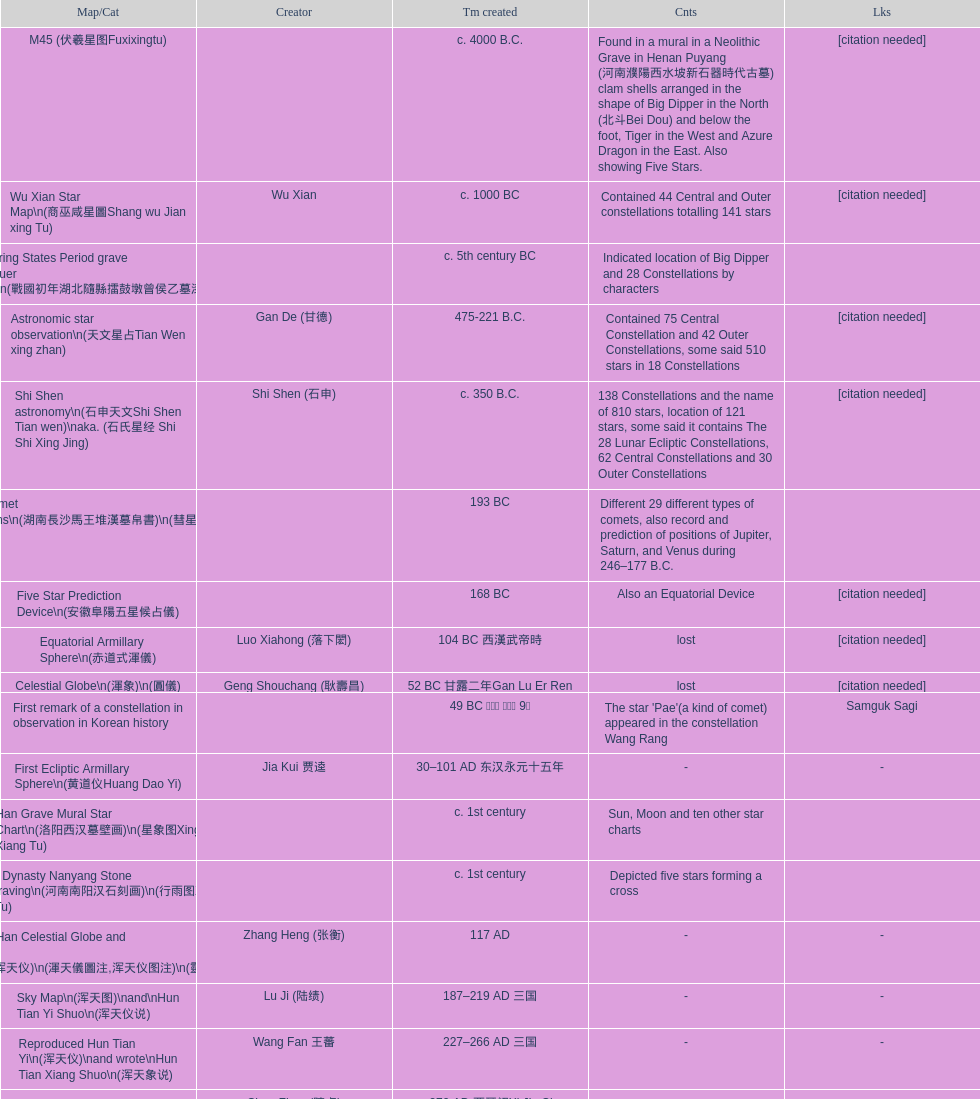Parse the full table. {'header': ['Map/Cat', 'Creator', 'Tm created', 'Cnts', 'Lks'], 'rows': [['M45 (伏羲星图Fuxixingtu)', '', 'c. 4000 B.C.', 'Found in a mural in a Neolithic Grave in Henan Puyang (河南濮陽西水坡新石器時代古墓) clam shells arranged in the shape of Big Dipper in the North (北斗Bei Dou) and below the foot, Tiger in the West and Azure Dragon in the East. Also showing Five Stars.', '[citation needed]'], ['Wu Xian Star Map\\n(商巫咸星圖Shang wu Jian xing Tu)', 'Wu Xian', 'c. 1000 BC', 'Contained 44 Central and Outer constellations totalling 141 stars', '[citation needed]'], ['Warring States Period grave lacquer box\\n(戰國初年湖北隨縣擂鼓墩曾侯乙墓漆箱)', '', 'c. 5th century BC', 'Indicated location of Big Dipper and 28 Constellations by characters', ''], ['Astronomic star observation\\n(天文星占Tian Wen xing zhan)', 'Gan De (甘德)', '475-221 B.C.', 'Contained 75 Central Constellation and 42 Outer Constellations, some said 510 stars in 18 Constellations', '[citation needed]'], ['Shi Shen astronomy\\n(石申天文Shi Shen Tian wen)\\naka. (石氏星经 Shi Shi Xing Jing)', 'Shi Shen (石申)', 'c. 350 B.C.', '138 Constellations and the name of 810 stars, location of 121 stars, some said it contains The 28 Lunar Ecliptic Constellations, 62 Central Constellations and 30 Outer Constellations', '[citation needed]'], ['Han Comet Diagrams\\n(湖南長沙馬王堆漢墓帛書)\\n(彗星圖Meng xing Tu)', '', '193 BC', 'Different 29 different types of comets, also record and prediction of positions of Jupiter, Saturn, and Venus during 246–177 B.C.', ''], ['Five Star Prediction Device\\n(安徽阜陽五星候占儀)', '', '168 BC', 'Also an Equatorial Device', '[citation needed]'], ['Equatorial Armillary Sphere\\n(赤道式渾儀)', 'Luo Xiahong (落下閎)', '104 BC 西漢武帝時', 'lost', '[citation needed]'], ['Celestial Globe\\n(渾象)\\n(圓儀)', 'Geng Shouchang (耿壽昌)', '52 BC 甘露二年Gan Lu Er Ren', 'lost', '[citation needed]'], ['First remark of a constellation in observation in Korean history', '', '49 BC 혁거세 거서간 9년', "The star 'Pae'(a kind of comet) appeared in the constellation Wang Rang", 'Samguk Sagi'], ['First Ecliptic Armillary Sphere\\n(黄道仪Huang Dao Yi)', 'Jia Kui 贾逵', '30–101 AD 东汉永元十五年', '-', '-'], ['Han Grave Mural Star Chart\\n(洛阳西汉墓壁画)\\n(星象图Xing Xiang Tu)', '', 'c. 1st century', 'Sun, Moon and ten other star charts', ''], ['Han Dynasty Nanyang Stone Engraving\\n(河南南阳汉石刻画)\\n(行雨图Xing Yu Tu)', '', 'c. 1st century', 'Depicted five stars forming a cross', ''], ['Eastern Han Celestial Globe and star maps\\n(浑天仪)\\n(渾天儀圖注,浑天仪图注)\\n(靈憲,灵宪)', 'Zhang Heng (张衡)', '117 AD', '-', '-'], ['Sky Map\\n(浑天图)\\nand\\nHun Tian Yi Shuo\\n(浑天仪说)', 'Lu Ji (陆绩)', '187–219 AD 三国', '-', '-'], ['Reproduced Hun Tian Yi\\n(浑天仪)\\nand wrote\\nHun Tian Xiang Shuo\\n(浑天象说)', 'Wang Fan 王蕃', '227–266 AD 三国', '-', '-'], ['Whole Sky Star Maps\\n(全天星圖Quan Tian Xing Tu)', 'Chen Zhuo (陳卓)', 'c. 270 AD 西晉初Xi Jin Chu', 'A Unified Constellation System. Star maps containing 1464 stars in 284 Constellations, written astrology text', '-'], ['Equatorial Armillary Sphere\\n(渾儀Hun Xi)', 'Kong Ting (孔挺)', '323 AD 東晉 前趙光初六年', 'level being used in this kind of device', '-'], ['Northern Wei Period Iron Armillary Sphere\\n(鐵渾儀)', 'Hu Lan (斛蘭)', 'Bei Wei\\plevel being used in this kind of device', '-', ''], ['Southern Dynasties Period Whole Sky Planetarium\\n(渾天象Hun Tian Xiang)', 'Qian Lezhi (錢樂之)', '443 AD 南朝劉宋元嘉年間', 'used red, black and white to differentiate stars from different star maps from Shi Shen, Gan De and Wu Xian 甘, 石, 巫三家星', '-'], ['Northern Wei Grave Dome Star Map\\n(河南洛陽北魏墓頂星圖)', '', '526 AD 北魏孝昌二年', 'about 300 stars, including the Big Dipper, some stars are linked by straight lines to form constellation. The Milky Way is also shown.', ''], ['Water-powered Planetarium\\n(水力渾天儀)', 'Geng Xun (耿詢)', 'c. 7th century 隋初Sui Chu', '-', '-'], ['Lingtai Miyuan\\n(靈台秘苑)', 'Yu Jicai (庾季才) and Zhou Fen (周墳)', '604 AD 隋Sui', 'incorporated star maps from different sources', '-'], ['Tang Dynasty Whole Sky Ecliptic Armillary Sphere\\n(渾天黃道儀)', 'Li Chunfeng 李淳風', '667 AD 貞觀七年', 'including Elliptic and Moon orbit, in addition to old equatorial design', '-'], ['The Dunhuang star map\\n(燉煌)', 'Dun Huang', '705–710 AD', '1,585 stars grouped into 257 clusters or "asterisms"', ''], ['Turfan Tomb Star Mural\\n(新疆吐鲁番阿斯塔那天文壁画)', '', '250–799 AD 唐', '28 Constellations, Milkyway and Five Stars', ''], ['Picture of Fuxi and Nüwa 新疆阿斯達那唐墓伏羲Fu Xi 女媧NV Wa像Xiang', '', 'Tang Dynasty', 'Picture of Fuxi and Nuwa together with some constellations', 'Image:Nuva fuxi.gif'], ['Tang Dynasty Armillary Sphere\\n(唐代渾儀Tang Dai Hun Xi)\\n(黃道遊儀Huang dao you xi)', 'Yixing Monk 一行和尚 (张遂)Zhang Sui and Liang Lingzan 梁令瓚', '683–727 AD', 'based on Han Dynasty Celestial Globe, recalibrated locations of 150 stars, determined that stars are moving', ''], ['Tang Dynasty Indian Horoscope Chart\\n(梵天火羅九曜)', 'Yixing Priest 一行和尚 (张遂)\\pZhang Sui\\p683–727 AD', 'simple diagrams of the 28 Constellation', '', ''], ['Kitora Kofun 法隆寺FaLong Si\u3000キトラ古墳 in Japan', '', 'c. late 7th century – early 8th century', 'Detailed whole sky map', ''], ['Treatise on Astrology of the Kaiyuan Era\\n(開元占経,开元占经Kai Yuan zhang Jing)', 'Gautama Siddha', '713 AD –', 'Collection of the three old star charts from Shi Shen, Gan De and Wu Xian. One of the most renowned collection recognized academically.', '-'], ['Big Dipper\\n(山東嘉祥武梁寺石刻北斗星)', '', '–', 'showing stars in Big Dipper', ''], ['Prajvalonisa Vjrabhairava Padvinasa-sri-dharani Scroll found in Japan 熾盛光佛頂大威德銷災吉祥陀羅尼經卷首扉畫', '', '972 AD 北宋開寶五年', 'Chinese 28 Constellations and Western Zodiac', '-'], ['Tangut Khara-Khoto (The Black City) Star Map 西夏黑水城星圖', '', '940 AD', 'A typical Qian Lezhi Style Star Map', '-'], ['Star Chart 五代吳越文穆王前元瓘墓石刻星象圖', '', '941–960 AD', '-', ''], ['Ancient Star Map 先天图 by 陈抟Chen Tuan', '', 'c. 11th Chen Tuan 宋Song', 'Perhaps based on studying of Puyong Ancient Star Map', 'Lost'], ['Song Dynasty Bronze Armillary Sphere 北宋至道銅渾儀', 'Han Xianfu 韓顯符', '1006 AD 宋道元年十二月', 'Similar to the Simplified Armillary by Kong Ting 孔挺, 晁崇 Chao Chong, 斛蘭 Hu Lan', '-'], ['Song Dynasty Bronze Armillary Sphere 北宋天文院黄道渾儀', 'Shu Yijian 舒易簡, Yu Yuan 于渊, Zhou Cong 周琮', '宋皇祐年中', 'Similar to the Armillary by Tang Dynasty Liang Lingzan 梁令瓚 and Yi Xing 一行', '-'], ['Song Dynasty Armillary Sphere 北宋簡化渾儀', 'Shen Kuo 沈括 and Huangfu Yu 皇甫愈', '1089 AD 熙寧七年', 'Simplied version of Tang Dynasty Device, removed the rarely used moon orbit.', '-'], ['Five Star Charts (新儀象法要)', 'Su Song 蘇頌', '1094 AD', '1464 stars grouped into 283 asterisms', 'Image:Su Song Star Map 1.JPG\\nImage:Su Song Star Map 2.JPG'], ['Song Dynasty Water-powered Planetarium 宋代 水运仪象台', 'Su Song 蘇頌 and Han Gonglian 韩公廉', 'c. 11th century', '-', ''], ['Liao Dynasty Tomb Dome Star Map 遼宣化张世卿墓頂星圖', '', '1116 AD 遼天庆六年', 'shown both the Chinese 28 Constellation encircled by Babylonian Zodiac', ''], ["Star Map in a woman's grave (江西德安 南宋周氏墓星相图)", '', '1127–1279 AD', 'Milky Way and 57 other stars.', ''], ['Hun Tian Yi Tong Xing Xiang Quan Tu, Suzhou Star Chart (蘇州石刻天文圖),淳祐天文図', 'Huang Shang (黃裳)', 'created in 1193, etched to stone in 1247 by Wang Zhi Yuan 王致遠', '1434 Stars grouped into 280 Asterisms in Northern Sky map', ''], ['Yuan Dynasty Simplified Armillary Sphere 元代簡儀', 'Guo Shou Jing 郭守敬', '1276–1279', 'Further simplied version of Song Dynasty Device', ''], ['Japanese Star Chart 格子月進図', '', '1324', 'Similar to Su Song Star Chart, original burned in air raids during World War II, only pictures left. Reprinted in 1984 by 佐佐木英治', ''], ['天象列次分野之図(Cheonsang Yeolcha Bunyajido)', '', '1395', 'Korean versions of Star Map in Stone. It was made in Chosun Dynasty and the constellation names were written in Chinese letter. The constellations as this was found in Japanese later. Contained 1,464 stars.', ''], ['Japanese Star Chart 瀧谷寺 天之図', '', 'c. 14th or 15th centuries 室町中期以前', '-', ''], ["Korean King Sejong's Armillary sphere", '', '1433', '-', ''], ['Star Chart', 'Mao Kun 茅坤', 'c. 1422', 'Polaris compared with Southern Cross and Alpha Centauri', 'zh:郑和航海图'], ['Korean Tomb', '', 'c. late 14th century', 'Big Dipper', ''], ['Ming Ancient Star Chart 北京隆福寺(古星圖)', '', 'c. 1453 明代', '1420 Stars, possibly based on old star maps from Tang Dynasty', ''], ['Chanshu Star Chart (明常熟石刻天文圖)', '', '1506', 'Based on Suzhou Star Chart, Northern Sky observed at 36.8 degrees North Latitude, 1466 stars grouped into 284 asterism', '-'], ['Ming Dynasty Star Map (渾蓋通憲圖說)', 'Matteo Ricci 利玛窦Li Ma Dou, recorded by Li Zhizao 李之藻', 'c. 1550', '-', ''], ['Tian Wun Tu (天问图)', 'Xiao Yun Cong 萧云从', 'c. 1600', 'Contained mapping of 12 constellations and 12 animals', ''], ['Zhou Tian Xuan Ji Tu (周天璇玑图) and He He Si Xiang Tu (和合四象圖) in Xing Ming Gui Zhi (性命圭旨)', 'by 尹真人高第弟子 published by 余永宁', '1615', 'Drawings of Armillary Sphere and four Chinese Celestial Animals with some notes. Related to Taoism.', ''], ['Korean Astronomy Book "Selected and Systematized Astronomy Notes" 天文類抄', '', '1623~1649', 'Contained some star maps', ''], ['Ming Dynasty General Star Map (赤道南北兩總星圖)', 'Xu Guang ci 徐光啟 and Adam Schall von Bell Tang Ruo Wang湯若望', '1634', '-', ''], ['Ming Dynasty diagrams of Armillary spheres and Celestial Globes', 'Xu Guang ci 徐光啟', 'c. 1699', '-', ''], ['Ming Dynasty Planetarium Machine (渾象 Hui Xiang)', '', 'c. 17th century', 'Ecliptic, Equator, and dividers of 28 constellation', ''], ['Copper Plate Star Map stored in Korea', '', '1652 順治九年shun zi jiu nian', '-', ''], ['Japanese Edo period Star Chart 天象列次之図 based on 天象列次分野之図 from Korean', 'Harumi Shibukawa 渋川春海Bu Chuan Chun Mei(保井春海Bao Jing Chun Mei)', '1670 寛文十年', '-', ''], ['The Celestial Globe 清康熙 天體儀', 'Ferdinand Verbiest 南懷仁', '1673', '1876 stars grouped into 282 asterisms', ''], ['Picture depicted Song Dynasty fictional astronomer (呉用 Wu Yong) with a Celestial Globe (天體儀)', 'Japanese painter', '1675', 'showing top portion of a Celestial Globe', 'File:Chinese astronomer 1675.jpg'], ['Japanese Edo period Star Chart 天文分野之図', 'Harumi Shibukawa 渋川春海BuJingChun Mei (保井春海Bao JingChunMei)', '1677 延宝五年', '-', ''], ['Korean star map in stone', '', '1687', '-', ''], ['Japanese Edo period Star Chart 天文図解', '井口常範', '1689 元禄2年', '-', '-'], ['Japanese Edo period Star Chart 古暦便覧備考', '苗村丈伯Mao Chun Zhang Bo', '1692 元禄5年', '-', '-'], ['Japanese star chart', 'Harumi Yasui written in Chinese', '1699 AD', 'A Japanese star chart of 1699 showing lunar stations', ''], ['Japanese Edo period Star Chart 天文成象Tian Wen Cheng xiang', '(渋川昔尹She Chuan Xi Yin) (保井昔尹Bao Jing Xi Yin)', '1699 元禄十二年', 'including Stars from Wu Shien (44 Constellation, 144 stars) in yellow; Gan De (118 Constellations, 511 stars) in black; Shi Shen (138 Constellations, 810 stars) in red and Harumi Shibukawa (61 Constellations, 308 stars) in blue;', ''], ['Japanese Star Chart 改正天文図説', '', 'unknown', 'Included stars from Harumi Shibukawa', ''], ['Korean Star Map Stone', '', 'c. 17th century', '-', ''], ['Korean Star Map', '', 'c. 17th century', '-', ''], ['Ceramic Ink Sink Cover', '', 'c. 17th century', 'Showing Big Dipper', ''], ['Korean Star Map Cube 方星圖', 'Italian Missionary Philippus Maria Grimardi 閔明我 (1639~1712)', 'c. early 18th century', '-', ''], ['Star Chart preserved in Japan based on a book from China 天経或問', 'You Zi liu 游子六', '1730 AD 江戸時代 享保15年', 'A Northern Sky Chart in Chinese', ''], ['Star Chart 清蒙文石刻(欽天監繪製天文圖) in Mongolia', '', '1727–1732 AD', '1550 stars grouped into 270 starisms.', ''], ['Korean Star Maps, North and South to the Eclliptic 黃道南北恒星圖', '', '1742', '-', ''], ['Japanese Edo period Star Chart 天経或問註解図巻\u3000下', '入江脩敬Ru Jiang YOu Jing', '1750 寛延3年', '-', '-'], ['Reproduction of an ancient device 璇璣玉衡', 'Dai Zhen 戴震', '1723–1777 AD', 'based on ancient record and his own interpretation', 'Could be similar to'], ['Rock Star Chart 清代天文石', '', 'c. 18th century', 'A Star Chart and general Astronomy Text', ''], ['Korean Complete Star Map (渾天全圖)', '', 'c. 18th century', '-', ''], ['Qing Dynasty Star Catalog (儀象考成,仪象考成)恒星表 and Star Map 黄道南北両星総図', 'Yun Lu 允禄 and Ignatius Kogler 戴进贤Dai Jin Xian 戴進賢, a German', 'Device made in 1744, book completed in 1757 清乾隆年间', '300 Constellations and 3083 Stars. Referenced Star Catalogue published by John Flamsteed', ''], ['Jingban Tianwen Quantu by Ma Junliang 马俊良', '', '1780–90 AD', 'mapping nations to the sky', ''], ['Japanese Edo period Illustration of a Star Measuring Device 平天儀図解', 'Yan Qiao Shan Bing Heng 岩橋善兵衛', '1802 Xiang He Er Nian 享和二年', '-', 'The device could be similar to'], ['North Sky Map 清嘉庆年间Huang Dao Zhong Xi He Tu(黄道中西合图)', 'Xu Choujun 徐朝俊', '1807 AD', 'More than 1000 stars and the 28 consellation', ''], ['Japanese Edo period Star Chart 天象総星之図', 'Chao Ye Bei Shui 朝野北水', '1814 文化十一年', '-', '-'], ['Japanese Edo period Star Chart 新制天球星象記', '田中政均', '1815 文化十二年', '-', '-'], ['Japanese Edo period Star Chart 天球図', '坂部廣胖', '1816 文化十三年', '-', '-'], ['Chinese Star map', 'John Reeves esq', '1819 AD', 'Printed map showing Chinese names of stars and constellations', ''], ['Japanese Edo period Star Chart 昊天図説詳解', '佐藤祐之', '1824 文政七年', '-', '-'], ['Japanese Edo period Star Chart 星図歩天歌', '小島好謙 and 鈴木世孝', '1824 文政七年', '-', '-'], ['Japanese Edo period Star Chart', '鈴木世孝', '1824 文政七年', '-', '-'], ['Japanese Edo period Star Chart 天象管鈔 天体図 (天文星象図解)', '長久保赤水', '1824 文政七年', '-', ''], ['Japanese Edo period Star Measuring Device 中星儀', '足立信順Zhu Li Xin Shun', '1824 文政七年', '-', '-'], ['Japanese Star Map 天象一覧図 in Kanji', '桜田虎門', '1824 AD 文政７年', 'Printed map showing Chinese names of stars and constellations', ''], ['Korean Star Map 天象列次分野之図 in Kanji', '', 'c. 19th century', 'Printed map showing Chinese names of stars and constellations', '[18]'], ['Korean Star Map', '', 'c. 19th century, late Choson Period', '-', ''], ['Korean Star maps: Star Map South to the Ecliptic 黃道南恒星圖 and Star Map South to the Ecliptic 黃道北恒星圖', '', 'c. 19th century', 'Perhaps influenced by Adam Schall von Bell Tang Ruo wang 湯若望 (1591–1666) and P. Ignatius Koegler 戴進賢 (1680–1748)', ''], ['Korean Complete map of the celestial sphere (渾天全圖)', '', 'c. 19th century', '-', ''], ['Korean Book of Stars 經星', '', 'c. 19th century', 'Several star maps', ''], ['Japanese Edo period Star Chart 方円星図,方圓星図 and 増補分度星図方図', '石坂常堅', '1826b文政9年', '-', '-'], ['Japanese Star Chart', '伊能忠誨', 'c. 19th century', '-', '-'], ['Japanese Edo period Star Chart 天球図説', '古筆源了材', '1835 天保6年', '-', '-'], ['Qing Dynasty Star Catalog (儀象考成續編)星表', '', '1844', 'Appendix to Yi Xian Kao Cheng, listed 3240 stars (added 163, removed 6)', ''], ['Stars map (恒星赤道経緯度図)stored in Japan', '', '1844 道光24年 or 1848', '-', '-'], ['Japanese Edo period Star Chart 経緯簡儀用法', '藤岡有貞', '1845 弘化２年', '-', '-'], ['Japanese Edo period Star Chart 分野星図', '高塚福昌, 阿部比輔, 上条景弘', '1849 嘉永2年', '-', '-'], ['Japanese Late Edo period Star Chart 天文図屏風', '遠藤盛俊', 'late Edo Period 江戸時代後期', '-', '-'], ['Japanese Star Chart 天体図', '三浦梅園', '-', '-', '-'], ['Japanese Star Chart 梅園星図', '高橋景保', '-', '-', ''], ['Korean Book of New Song of the Sky Pacer 新法步天歌', '李俊養', '1862', 'Star maps and a revised version of the Song of Sky Pacer', ''], ['Stars South of Equator, Stars North of Equator (赤道南恆星圖,赤道北恆星圖)', '', '1875～1908 清末光緒年間', 'Similar to Ming Dynasty General Star Map', ''], ['Fuxi 64 gua 28 xu wood carving 天水市卦台山伏羲六十四卦二十八宿全图', '', 'modern', '-', '-'], ['Korean Map of Heaven and Earth 天地圖', '', 'c. 19th century', '28 Constellations and geographic map', ''], ['Korean version of 28 Constellation 列宿圖', '', 'c. 19th century', '28 Constellations, some named differently from their Chinese counterparts', ''], ['Korean Star Chart 渾天図', '朴?', '-', '-', '-'], ['Star Chart in a Dao Temple 玉皇山道觀星圖', '', '1940 AD', '-', '-'], ['Simplified Chinese and Western Star Map', 'Yi Shi Tong 伊世同', 'Aug. 1963', 'Star Map showing Chinese Xingquan and Western Constellation boundaries', ''], ['Sky Map', 'Yu Xi Dao Ren 玉溪道人', '1987', 'Star Map with captions', ''], ['The Chinese Sky during the Han Constellating Stars and Society', 'Sun Xiaochun and Jacob Kistemaker', '1997 AD', 'An attempt to recreate night sky seen by Chinese 2000 years ago', ''], ['Star map', '', 'Recent', 'An attempt by a Japanese to reconstruct the night sky for a historical event around 235 AD 秋風五丈原', ''], ['Star maps', '', 'Recent', 'Chinese 28 Constellation with Chinese and Japanese captions', ''], ['SinoSky Beta 2.0', '', '2002', 'A computer program capable of showing Chinese Xingguans alongside with western constellations, lists about 700 stars with Chinese names.', ''], ['AEEA Star maps', '', 'Modern', 'Good reconstruction and explanation of Chinese constellations', ''], ['Wikipedia Star maps', '', 'Modern', '-', 'zh:華蓋星'], ['28 Constellations, big dipper and 4 symbols Star map', '', 'Modern', '-', ''], ['Collection of printed star maps', '', 'Modern', '-', ''], ['28 Xu Star map and catalog', '-', 'Modern', 'Stars around ecliptic', ''], ['HNSKY Korean/Chinese Supplement', 'Jeong, Tae-Min(jtm71)/Chuang_Siau_Chin', 'Modern', 'Korean supplement is based on CheonSangYeulChaBunYaZiDo (B.C.100 ~ A.D.100)', ''], ['Stellarium Chinese and Korean Sky Culture', 'G.S.K. Lee; Jeong, Tae-Min(jtm71); Yu-Pu Wang (evanzxcv)', 'Modern', 'Major Xingguans and Star names', ''], ['修真內外火侯全圖 Huo Hou Tu', 'Xi Chun Sheng Chong Hui\\p2005 redrawn, original unknown', 'illustrations of Milkyway and star maps, Chinese constellations in Taoism view', '', ''], ['Star Map with illustrations for Xingguans', '坐井★观星Zuo Jing Guan Xing', 'Modern', 'illustrations for cylindrical and circular polar maps', ''], ['Sky in Google Earth KML', '', 'Modern', 'Attempts to show Chinese Star Maps on Google Earth', '']]} Name three items created not long after the equatorial armillary sphere. Celestial Globe (渾象) (圓儀), First remark of a constellation in observation in Korean history, First Ecliptic Armillary Sphere (黄道仪Huang Dao Yi). 